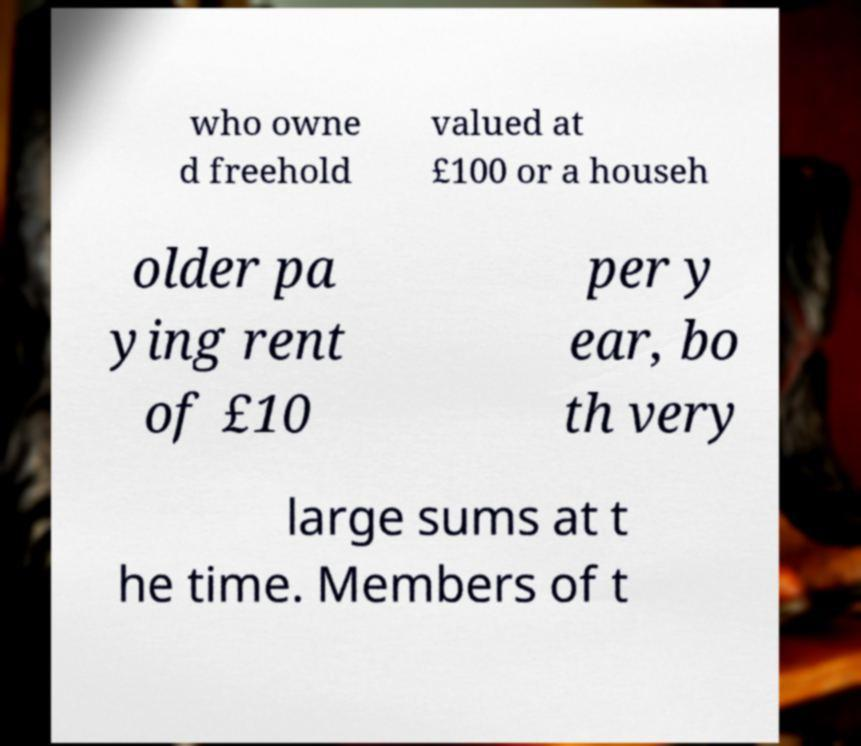Can you accurately transcribe the text from the provided image for me? who owne d freehold valued at £100 or a househ older pa ying rent of £10 per y ear, bo th very large sums at t he time. Members of t 